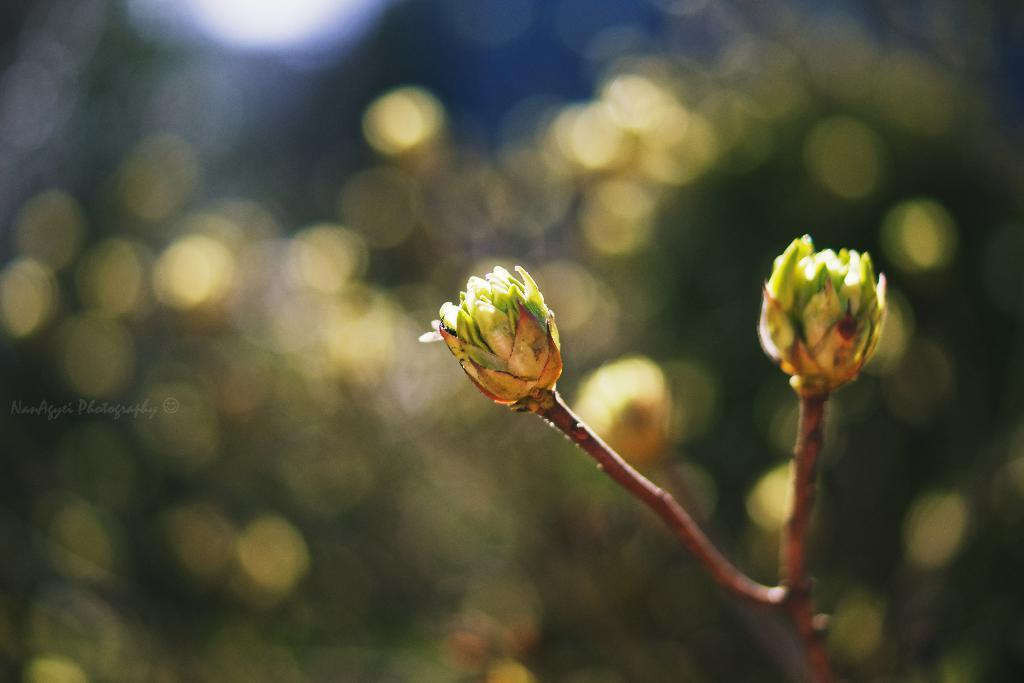What is present in the image? There is a plant in the image. What is the current state of the plant? The plant has buds. In which direction are the buds facing? The buds are towards the right. What type of work is the plant doing in the image? The plant is not performing any work in the image, as it is a living organism and not capable of performing work. 